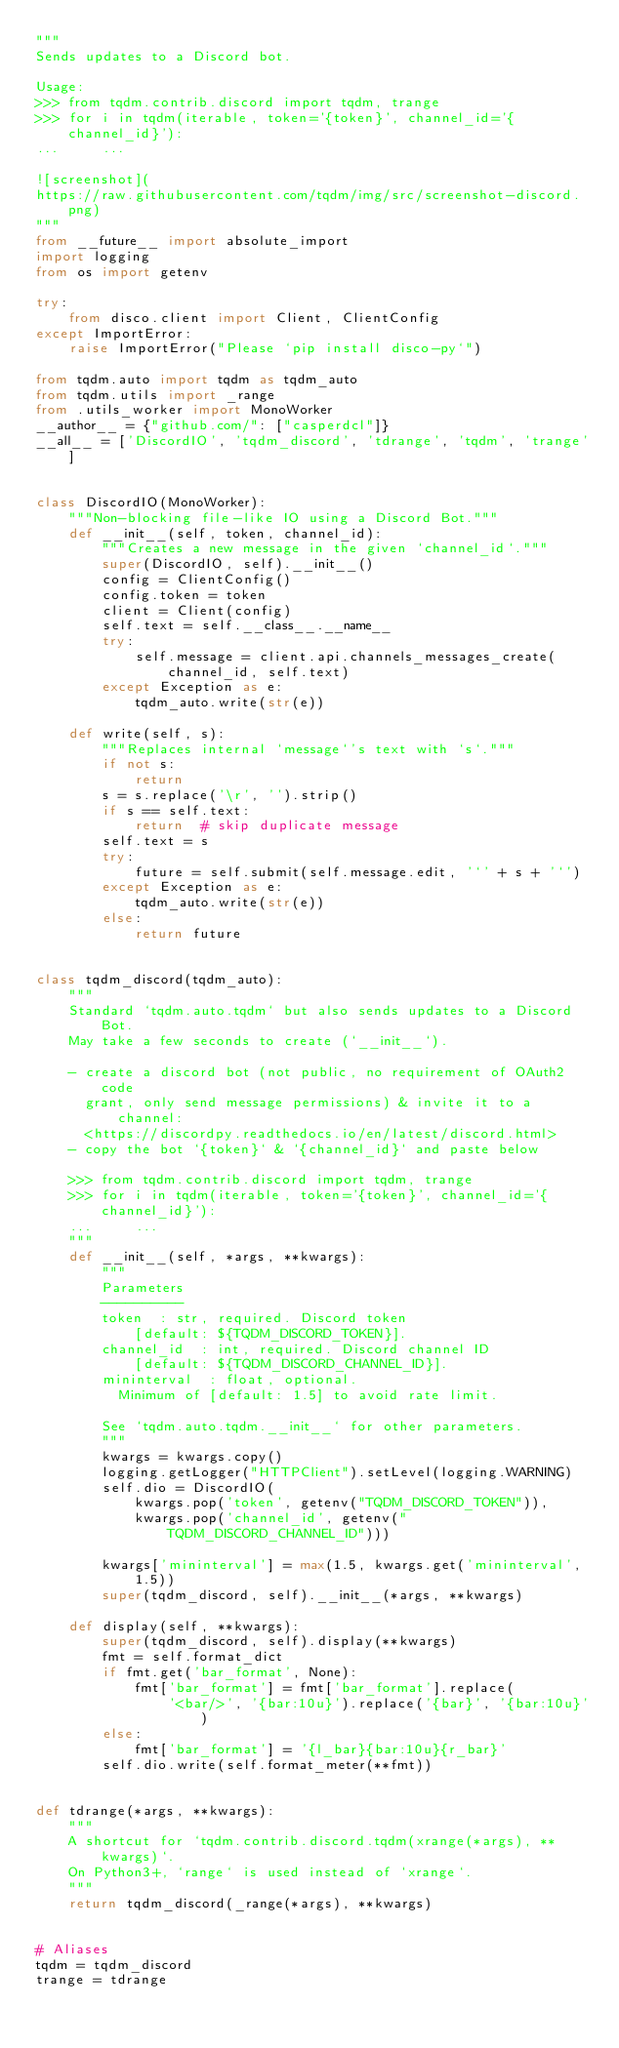<code> <loc_0><loc_0><loc_500><loc_500><_Python_>"""
Sends updates to a Discord bot.

Usage:
>>> from tqdm.contrib.discord import tqdm, trange
>>> for i in tqdm(iterable, token='{token}', channel_id='{channel_id}'):
...     ...

![screenshot](
https://raw.githubusercontent.com/tqdm/img/src/screenshot-discord.png)
"""
from __future__ import absolute_import
import logging
from os import getenv

try:
    from disco.client import Client, ClientConfig
except ImportError:
    raise ImportError("Please `pip install disco-py`")

from tqdm.auto import tqdm as tqdm_auto
from tqdm.utils import _range
from .utils_worker import MonoWorker
__author__ = {"github.com/": ["casperdcl"]}
__all__ = ['DiscordIO', 'tqdm_discord', 'tdrange', 'tqdm', 'trange']


class DiscordIO(MonoWorker):
    """Non-blocking file-like IO using a Discord Bot."""
    def __init__(self, token, channel_id):
        """Creates a new message in the given `channel_id`."""
        super(DiscordIO, self).__init__()
        config = ClientConfig()
        config.token = token
        client = Client(config)
        self.text = self.__class__.__name__
        try:
            self.message = client.api.channels_messages_create(
                channel_id, self.text)
        except Exception as e:
            tqdm_auto.write(str(e))

    def write(self, s):
        """Replaces internal `message`'s text with `s`."""
        if not s:
            return
        s = s.replace('\r', '').strip()
        if s == self.text:
            return  # skip duplicate message
        self.text = s
        try:
            future = self.submit(self.message.edit, '`' + s + '`')
        except Exception as e:
            tqdm_auto.write(str(e))
        else:
            return future


class tqdm_discord(tqdm_auto):
    """
    Standard `tqdm.auto.tqdm` but also sends updates to a Discord Bot.
    May take a few seconds to create (`__init__`).

    - create a discord bot (not public, no requirement of OAuth2 code
      grant, only send message permissions) & invite it to a channel:
      <https://discordpy.readthedocs.io/en/latest/discord.html>
    - copy the bot `{token}` & `{channel_id}` and paste below

    >>> from tqdm.contrib.discord import tqdm, trange
    >>> for i in tqdm(iterable, token='{token}', channel_id='{channel_id}'):
    ...     ...
    """
    def __init__(self, *args, **kwargs):
        """
        Parameters
        ----------
        token  : str, required. Discord token
            [default: ${TQDM_DISCORD_TOKEN}].
        channel_id  : int, required. Discord channel ID
            [default: ${TQDM_DISCORD_CHANNEL_ID}].
        mininterval  : float, optional.
          Minimum of [default: 1.5] to avoid rate limit.

        See `tqdm.auto.tqdm.__init__` for other parameters.
        """
        kwargs = kwargs.copy()
        logging.getLogger("HTTPClient").setLevel(logging.WARNING)
        self.dio = DiscordIO(
            kwargs.pop('token', getenv("TQDM_DISCORD_TOKEN")),
            kwargs.pop('channel_id', getenv("TQDM_DISCORD_CHANNEL_ID")))

        kwargs['mininterval'] = max(1.5, kwargs.get('mininterval', 1.5))
        super(tqdm_discord, self).__init__(*args, **kwargs)

    def display(self, **kwargs):
        super(tqdm_discord, self).display(**kwargs)
        fmt = self.format_dict
        if fmt.get('bar_format', None):
            fmt['bar_format'] = fmt['bar_format'].replace(
                '<bar/>', '{bar:10u}').replace('{bar}', '{bar:10u}')
        else:
            fmt['bar_format'] = '{l_bar}{bar:10u}{r_bar}'
        self.dio.write(self.format_meter(**fmt))


def tdrange(*args, **kwargs):
    """
    A shortcut for `tqdm.contrib.discord.tqdm(xrange(*args), **kwargs)`.
    On Python3+, `range` is used instead of `xrange`.
    """
    return tqdm_discord(_range(*args), **kwargs)


# Aliases
tqdm = tqdm_discord
trange = tdrange
</code> 